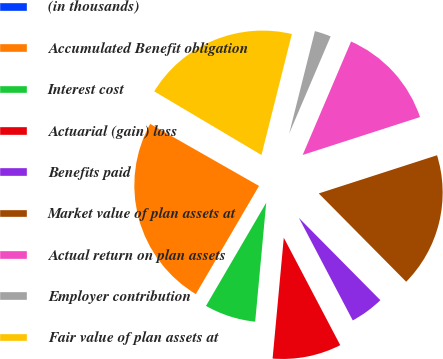Convert chart. <chart><loc_0><loc_0><loc_500><loc_500><pie_chart><fcel>(in thousands)<fcel>Accumulated Benefit obligation<fcel>Interest cost<fcel>Actuarial (gain) loss<fcel>Benefits paid<fcel>Market value of plan assets at<fcel>Actual return on plan assets<fcel>Employer contribution<fcel>Fair value of plan assets at<nl><fcel>0.28%<fcel>24.83%<fcel>6.94%<fcel>9.17%<fcel>4.72%<fcel>17.55%<fcel>13.61%<fcel>2.5%<fcel>20.39%<nl></chart> 